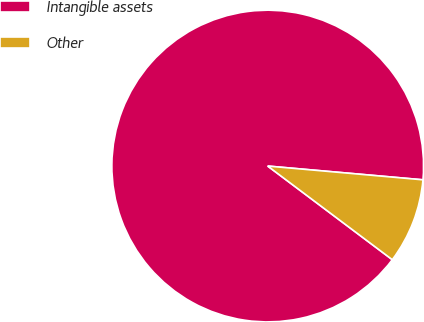Convert chart. <chart><loc_0><loc_0><loc_500><loc_500><pie_chart><fcel>Intangible assets<fcel>Other<nl><fcel>91.15%<fcel>8.85%<nl></chart> 